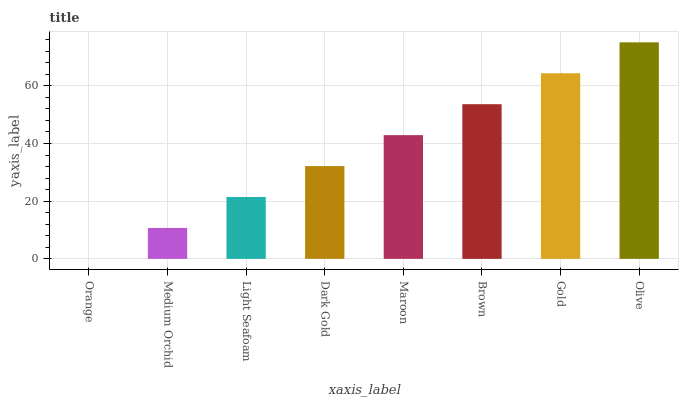Is Medium Orchid the minimum?
Answer yes or no. No. Is Medium Orchid the maximum?
Answer yes or no. No. Is Medium Orchid greater than Orange?
Answer yes or no. Yes. Is Orange less than Medium Orchid?
Answer yes or no. Yes. Is Orange greater than Medium Orchid?
Answer yes or no. No. Is Medium Orchid less than Orange?
Answer yes or no. No. Is Maroon the high median?
Answer yes or no. Yes. Is Dark Gold the low median?
Answer yes or no. Yes. Is Medium Orchid the high median?
Answer yes or no. No. Is Maroon the low median?
Answer yes or no. No. 